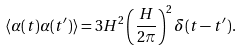<formula> <loc_0><loc_0><loc_500><loc_500>\langle \alpha ( t ) \alpha ( t ^ { \prime } ) \rangle = 3 H ^ { 2 } \left ( \frac { H } { 2 \pi } \right ) ^ { 2 } \delta ( t - t ^ { \prime } ) .</formula> 